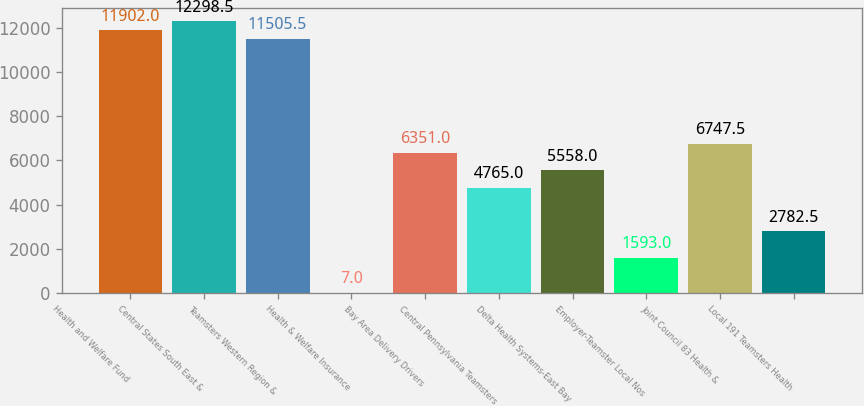Convert chart to OTSL. <chart><loc_0><loc_0><loc_500><loc_500><bar_chart><fcel>Health and Welfare Fund<fcel>Central States South East &<fcel>Teamsters Western Region &<fcel>Health & Welfare Insurance<fcel>Bay Area Delivery Drivers<fcel>Central Pennsylvania Teamsters<fcel>Delta Health Systems-East Bay<fcel>Employer-Teamster Local Nos<fcel>Joint Council 83 Health &<fcel>Local 191 Teamsters Health<nl><fcel>11902<fcel>12298.5<fcel>11505.5<fcel>7<fcel>6351<fcel>4765<fcel>5558<fcel>1593<fcel>6747.5<fcel>2782.5<nl></chart> 